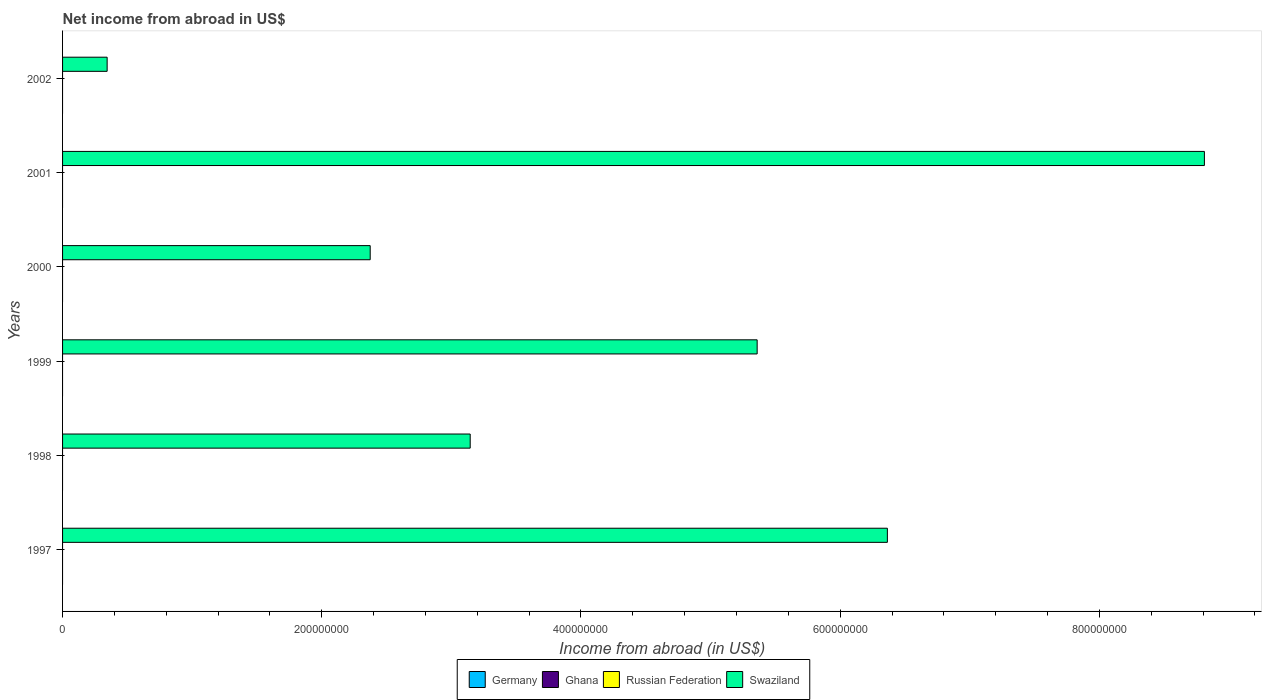How many different coloured bars are there?
Your answer should be very brief. 1. How many bars are there on the 6th tick from the bottom?
Keep it short and to the point. 1. What is the label of the 3rd group of bars from the top?
Your answer should be compact. 2000. In how many cases, is the number of bars for a given year not equal to the number of legend labels?
Keep it short and to the point. 6. What is the net income from abroad in Russian Federation in 1998?
Offer a terse response. 0. Across all years, what is the maximum net income from abroad in Swaziland?
Your answer should be very brief. 8.81e+08. What is the total net income from abroad in Swaziland in the graph?
Ensure brevity in your answer.  2.64e+09. What is the difference between the net income from abroad in Swaziland in 1998 and that in 2000?
Make the answer very short. 7.72e+07. What is the difference between the net income from abroad in Swaziland in 1999 and the net income from abroad in Ghana in 2001?
Your answer should be very brief. 5.36e+08. What is the ratio of the net income from abroad in Swaziland in 1997 to that in 1998?
Your answer should be very brief. 2.02. What is the difference between the highest and the second highest net income from abroad in Swaziland?
Offer a very short reply. 2.45e+08. What is the difference between the highest and the lowest net income from abroad in Swaziland?
Give a very brief answer. 8.47e+08. Is it the case that in every year, the sum of the net income from abroad in Russian Federation and net income from abroad in Germany is greater than the sum of net income from abroad in Swaziland and net income from abroad in Ghana?
Provide a short and direct response. No. Are all the bars in the graph horizontal?
Provide a succinct answer. Yes. How many legend labels are there?
Provide a succinct answer. 4. What is the title of the graph?
Provide a succinct answer. Net income from abroad in US$. Does "North America" appear as one of the legend labels in the graph?
Your response must be concise. No. What is the label or title of the X-axis?
Offer a very short reply. Income from abroad (in US$). What is the Income from abroad (in US$) in Germany in 1997?
Your answer should be compact. 0. What is the Income from abroad (in US$) of Ghana in 1997?
Keep it short and to the point. 0. What is the Income from abroad (in US$) in Russian Federation in 1997?
Your answer should be very brief. 0. What is the Income from abroad (in US$) in Swaziland in 1997?
Provide a succinct answer. 6.36e+08. What is the Income from abroad (in US$) of Germany in 1998?
Make the answer very short. 0. What is the Income from abroad (in US$) of Ghana in 1998?
Provide a succinct answer. 0. What is the Income from abroad (in US$) in Swaziland in 1998?
Ensure brevity in your answer.  3.15e+08. What is the Income from abroad (in US$) of Russian Federation in 1999?
Ensure brevity in your answer.  0. What is the Income from abroad (in US$) in Swaziland in 1999?
Provide a short and direct response. 5.36e+08. What is the Income from abroad (in US$) in Ghana in 2000?
Ensure brevity in your answer.  0. What is the Income from abroad (in US$) of Russian Federation in 2000?
Offer a very short reply. 0. What is the Income from abroad (in US$) in Swaziland in 2000?
Ensure brevity in your answer.  2.37e+08. What is the Income from abroad (in US$) in Russian Federation in 2001?
Make the answer very short. 0. What is the Income from abroad (in US$) of Swaziland in 2001?
Give a very brief answer. 8.81e+08. What is the Income from abroad (in US$) in Ghana in 2002?
Provide a succinct answer. 0. What is the Income from abroad (in US$) in Russian Federation in 2002?
Provide a short and direct response. 0. What is the Income from abroad (in US$) in Swaziland in 2002?
Your response must be concise. 3.44e+07. Across all years, what is the maximum Income from abroad (in US$) of Swaziland?
Make the answer very short. 8.81e+08. Across all years, what is the minimum Income from abroad (in US$) in Swaziland?
Provide a short and direct response. 3.44e+07. What is the total Income from abroad (in US$) in Germany in the graph?
Offer a very short reply. 0. What is the total Income from abroad (in US$) in Swaziland in the graph?
Ensure brevity in your answer.  2.64e+09. What is the difference between the Income from abroad (in US$) in Swaziland in 1997 and that in 1998?
Your answer should be compact. 3.22e+08. What is the difference between the Income from abroad (in US$) in Swaziland in 1997 and that in 1999?
Provide a succinct answer. 1.00e+08. What is the difference between the Income from abroad (in US$) in Swaziland in 1997 and that in 2000?
Offer a very short reply. 3.99e+08. What is the difference between the Income from abroad (in US$) in Swaziland in 1997 and that in 2001?
Give a very brief answer. -2.45e+08. What is the difference between the Income from abroad (in US$) of Swaziland in 1997 and that in 2002?
Ensure brevity in your answer.  6.02e+08. What is the difference between the Income from abroad (in US$) in Swaziland in 1998 and that in 1999?
Offer a very short reply. -2.21e+08. What is the difference between the Income from abroad (in US$) of Swaziland in 1998 and that in 2000?
Make the answer very short. 7.72e+07. What is the difference between the Income from abroad (in US$) in Swaziland in 1998 and that in 2001?
Your answer should be very brief. -5.66e+08. What is the difference between the Income from abroad (in US$) of Swaziland in 1998 and that in 2002?
Your answer should be compact. 2.80e+08. What is the difference between the Income from abroad (in US$) in Swaziland in 1999 and that in 2000?
Your answer should be compact. 2.99e+08. What is the difference between the Income from abroad (in US$) of Swaziland in 1999 and that in 2001?
Your answer should be compact. -3.45e+08. What is the difference between the Income from abroad (in US$) of Swaziland in 1999 and that in 2002?
Provide a short and direct response. 5.02e+08. What is the difference between the Income from abroad (in US$) in Swaziland in 2000 and that in 2001?
Provide a succinct answer. -6.44e+08. What is the difference between the Income from abroad (in US$) in Swaziland in 2000 and that in 2002?
Provide a succinct answer. 2.03e+08. What is the difference between the Income from abroad (in US$) of Swaziland in 2001 and that in 2002?
Your answer should be very brief. 8.47e+08. What is the average Income from abroad (in US$) in Germany per year?
Your response must be concise. 0. What is the average Income from abroad (in US$) in Ghana per year?
Give a very brief answer. 0. What is the average Income from abroad (in US$) of Russian Federation per year?
Offer a very short reply. 0. What is the average Income from abroad (in US$) of Swaziland per year?
Offer a very short reply. 4.40e+08. What is the ratio of the Income from abroad (in US$) in Swaziland in 1997 to that in 1998?
Give a very brief answer. 2.02. What is the ratio of the Income from abroad (in US$) of Swaziland in 1997 to that in 1999?
Your response must be concise. 1.19. What is the ratio of the Income from abroad (in US$) in Swaziland in 1997 to that in 2000?
Provide a short and direct response. 2.68. What is the ratio of the Income from abroad (in US$) in Swaziland in 1997 to that in 2001?
Provide a short and direct response. 0.72. What is the ratio of the Income from abroad (in US$) of Swaziland in 1997 to that in 2002?
Ensure brevity in your answer.  18.5. What is the ratio of the Income from abroad (in US$) of Swaziland in 1998 to that in 1999?
Offer a very short reply. 0.59. What is the ratio of the Income from abroad (in US$) of Swaziland in 1998 to that in 2000?
Offer a terse response. 1.33. What is the ratio of the Income from abroad (in US$) of Swaziland in 1998 to that in 2001?
Ensure brevity in your answer.  0.36. What is the ratio of the Income from abroad (in US$) of Swaziland in 1998 to that in 2002?
Give a very brief answer. 9.14. What is the ratio of the Income from abroad (in US$) in Swaziland in 1999 to that in 2000?
Your answer should be very brief. 2.26. What is the ratio of the Income from abroad (in US$) of Swaziland in 1999 to that in 2001?
Provide a short and direct response. 0.61. What is the ratio of the Income from abroad (in US$) in Swaziland in 1999 to that in 2002?
Make the answer very short. 15.58. What is the ratio of the Income from abroad (in US$) in Swaziland in 2000 to that in 2001?
Provide a succinct answer. 0.27. What is the ratio of the Income from abroad (in US$) of Swaziland in 2000 to that in 2002?
Give a very brief answer. 6.9. What is the ratio of the Income from abroad (in US$) of Swaziland in 2001 to that in 2002?
Offer a terse response. 25.61. What is the difference between the highest and the second highest Income from abroad (in US$) in Swaziland?
Your response must be concise. 2.45e+08. What is the difference between the highest and the lowest Income from abroad (in US$) of Swaziland?
Your answer should be compact. 8.47e+08. 